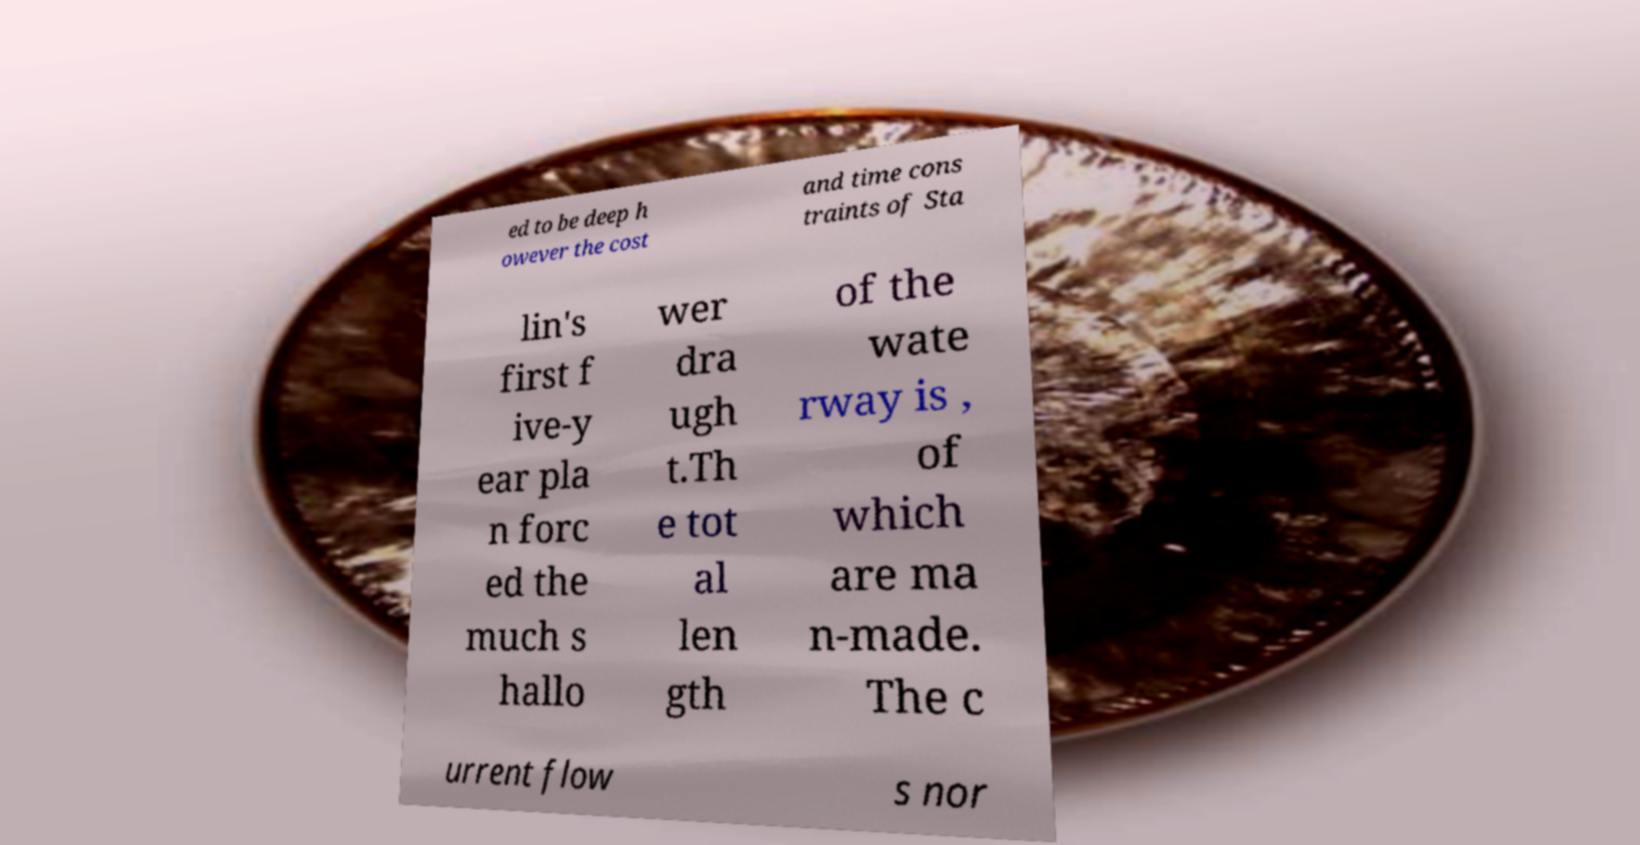Can you accurately transcribe the text from the provided image for me? ed to be deep h owever the cost and time cons traints of Sta lin's first f ive-y ear pla n forc ed the much s hallo wer dra ugh t.Th e tot al len gth of the wate rway is , of which are ma n-made. The c urrent flow s nor 